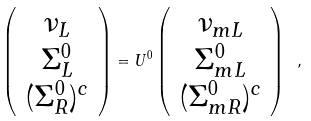Convert formula to latex. <formula><loc_0><loc_0><loc_500><loc_500>\left ( \begin{array} { c } \nu _ { L } \\ \Sigma ^ { 0 } _ { L } \\ ( \Sigma _ { R } ^ { 0 } ) ^ { c } \\ \end{array} \right ) = U ^ { 0 } \left ( \begin{array} { c } \nu _ { m L } \\ \Sigma ^ { 0 } _ { m L } \\ ( \Sigma _ { m R } ^ { 0 } ) ^ { c } \\ \end{array} \right ) \ ,</formula> 